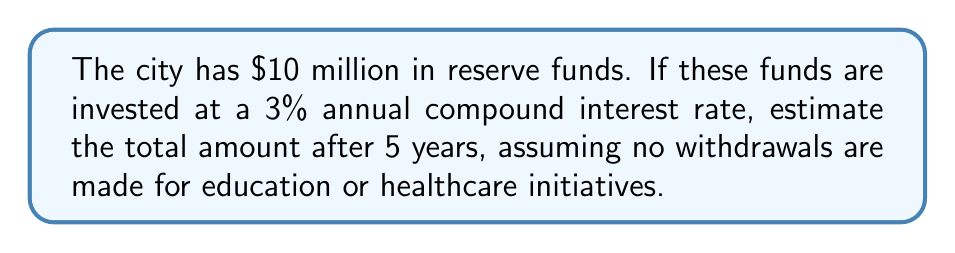Teach me how to tackle this problem. Let's approach this step-by-step:

1) The formula for compound interest is:
   $A = P(1 + r)^n$
   Where:
   $A$ = final amount
   $P$ = principal (initial investment)
   $r$ = annual interest rate (in decimal form)
   $n$ = number of years

2) We have:
   $P = \$10,000,000$
   $r = 3\% = 0.03$
   $n = 5$ years

3) Plugging these values into the formula:
   $A = 10,000,000(1 + 0.03)^5$

4) Let's calculate:
   $A = 10,000,000(1.03)^5$
   $A = 10,000,000(1.159274)$
   $A = 11,592,740$

5) Therefore, after 5 years, the reserve funds will grow to approximately $11,592,740.
Answer: $11,592,740 